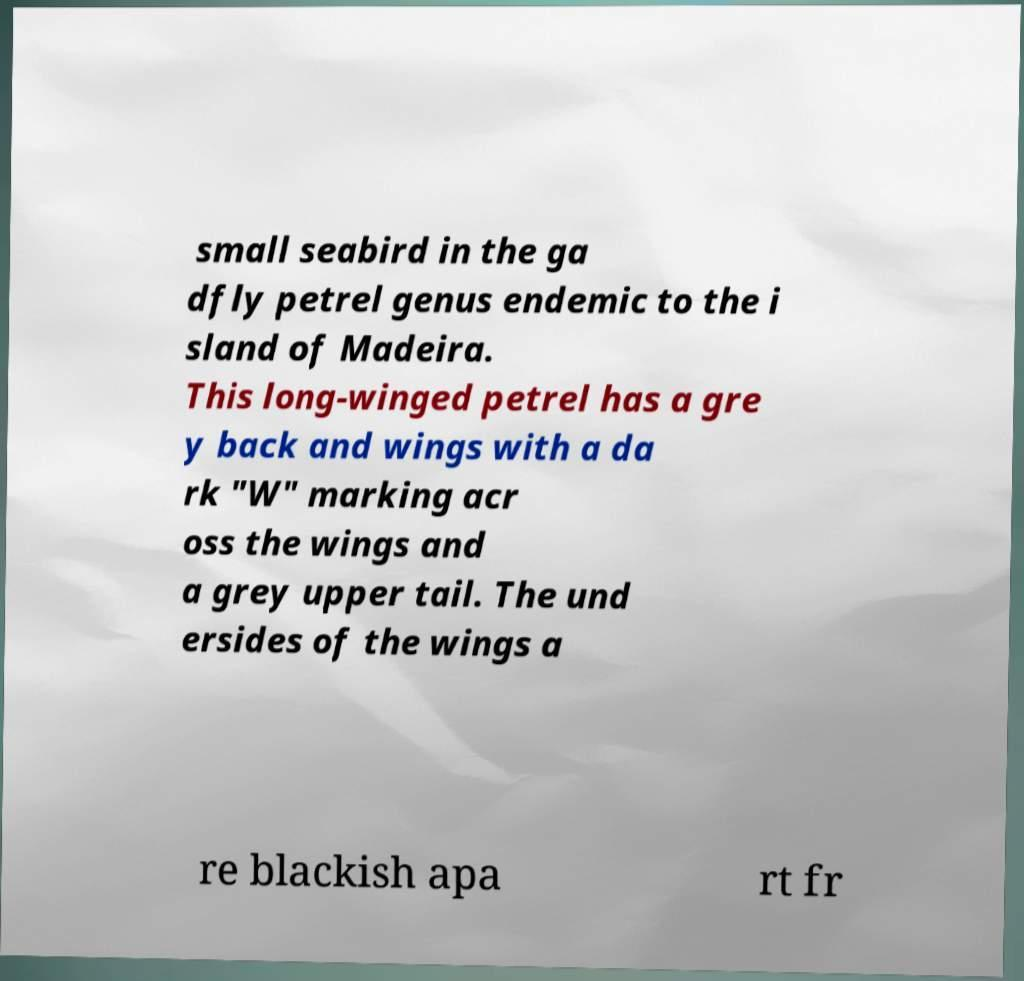What messages or text are displayed in this image? I need them in a readable, typed format. small seabird in the ga dfly petrel genus endemic to the i sland of Madeira. This long-winged petrel has a gre y back and wings with a da rk "W" marking acr oss the wings and a grey upper tail. The und ersides of the wings a re blackish apa rt fr 